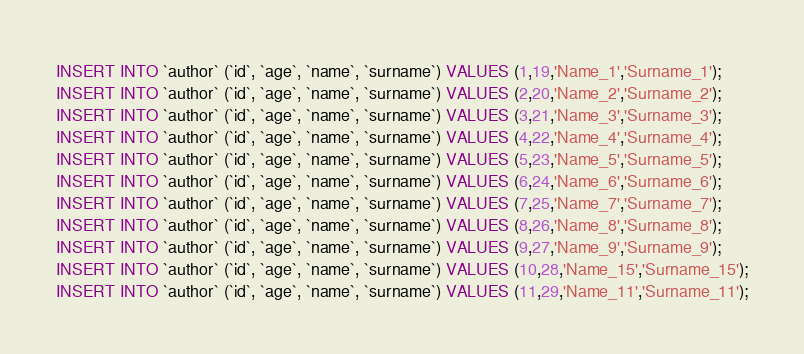<code> <loc_0><loc_0><loc_500><loc_500><_SQL_>INSERT INTO `author` (`id`, `age`, `name`, `surname`) VALUES (1,19,'Name_1','Surname_1');
INSERT INTO `author` (`id`, `age`, `name`, `surname`) VALUES (2,20,'Name_2','Surname_2');
INSERT INTO `author` (`id`, `age`, `name`, `surname`) VALUES (3,21,'Name_3','Surname_3');
INSERT INTO `author` (`id`, `age`, `name`, `surname`) VALUES (4,22,'Name_4','Surname_4');
INSERT INTO `author` (`id`, `age`, `name`, `surname`) VALUES (5,23,'Name_5','Surname_5');
INSERT INTO `author` (`id`, `age`, `name`, `surname`) VALUES (6,24,'Name_6','Surname_6');
INSERT INTO `author` (`id`, `age`, `name`, `surname`) VALUES (7,25,'Name_7','Surname_7');
INSERT INTO `author` (`id`, `age`, `name`, `surname`) VALUES (8,26,'Name_8','Surname_8');
INSERT INTO `author` (`id`, `age`, `name`, `surname`) VALUES (9,27,'Name_9','Surname_9');
INSERT INTO `author` (`id`, `age`, `name`, `surname`) VALUES (10,28,'Name_15','Surname_15');
INSERT INTO `author` (`id`, `age`, `name`, `surname`) VALUES (11,29,'Name_11','Surname_11');</code> 